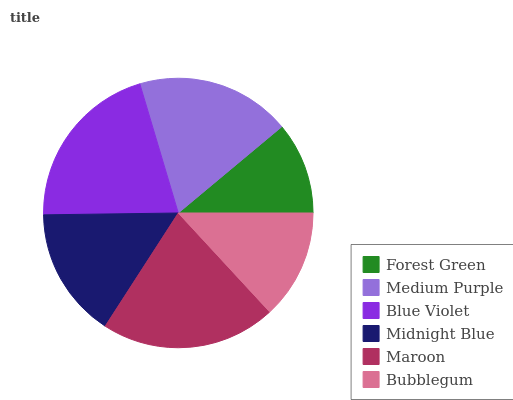Is Forest Green the minimum?
Answer yes or no. Yes. Is Maroon the maximum?
Answer yes or no. Yes. Is Medium Purple the minimum?
Answer yes or no. No. Is Medium Purple the maximum?
Answer yes or no. No. Is Medium Purple greater than Forest Green?
Answer yes or no. Yes. Is Forest Green less than Medium Purple?
Answer yes or no. Yes. Is Forest Green greater than Medium Purple?
Answer yes or no. No. Is Medium Purple less than Forest Green?
Answer yes or no. No. Is Medium Purple the high median?
Answer yes or no. Yes. Is Midnight Blue the low median?
Answer yes or no. Yes. Is Midnight Blue the high median?
Answer yes or no. No. Is Blue Violet the low median?
Answer yes or no. No. 